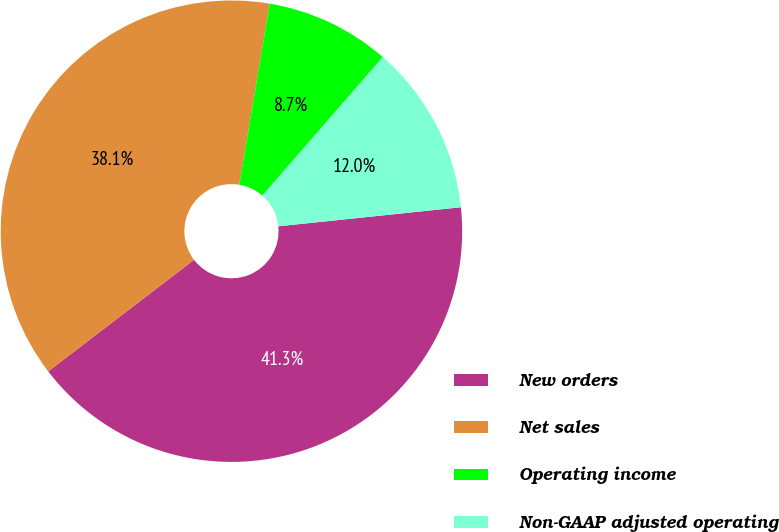<chart> <loc_0><loc_0><loc_500><loc_500><pie_chart><fcel>New orders<fcel>Net sales<fcel>Operating income<fcel>Non-GAAP adjusted operating<nl><fcel>41.26%<fcel>38.05%<fcel>8.74%<fcel>11.95%<nl></chart> 